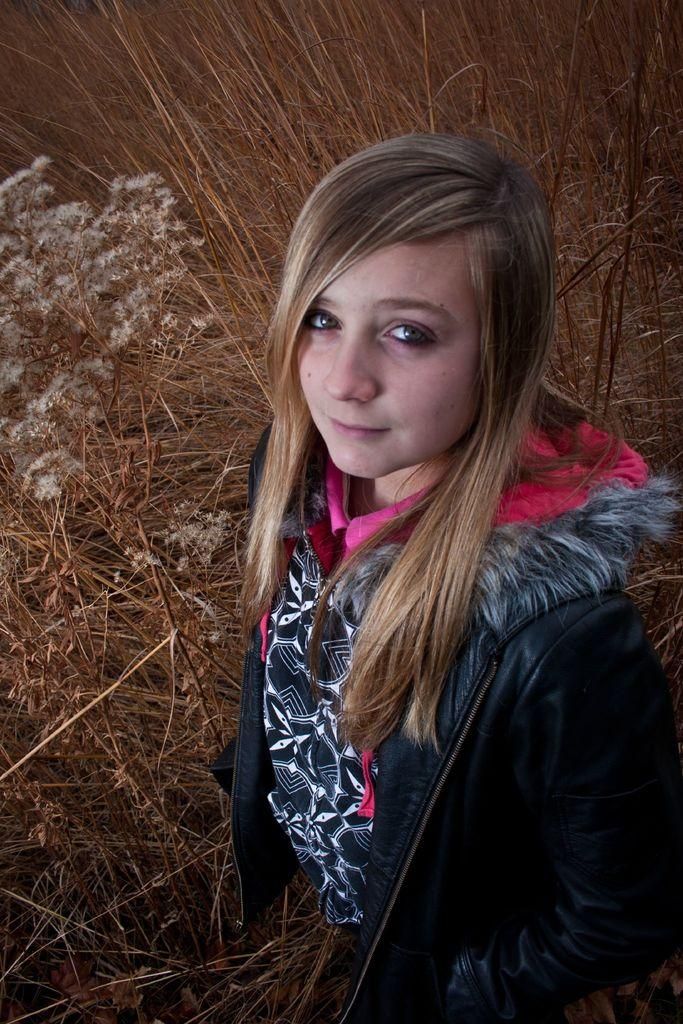Who is the main subject in the foreground of the picture? There is a girl in the foreground of the picture. What is the girl wearing? The girl is wearing a black jacket. What is the girl standing on? The girl is standing on the grass. What can be seen in the background of the image? There is visible in the background of the image. What type of vegetation is present in the background? The background includes grass. Can you see any mines in the image? There are no mines present in the image. What type of harbor can be seen in the background of the image? There is no harbor present in the image; the background only includes grass. 